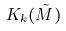Convert formula to latex. <formula><loc_0><loc_0><loc_500><loc_500>K _ { k } ( \tilde { M } )</formula> 